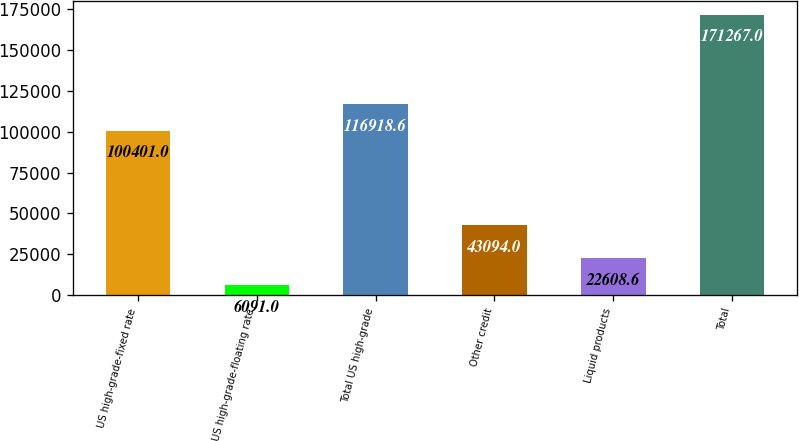Convert chart to OTSL. <chart><loc_0><loc_0><loc_500><loc_500><bar_chart><fcel>US high-grade-fixed rate<fcel>US high-grade-floating rate<fcel>Total US high-grade<fcel>Other credit<fcel>Liquid products<fcel>Total<nl><fcel>100401<fcel>6091<fcel>116919<fcel>43094<fcel>22608.6<fcel>171267<nl></chart> 